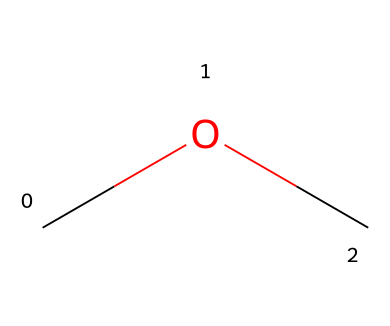What is the molecular formula of this compound? The SMILES representation "COC" indicates that there are 2 carbon atoms (C), 6 hydrogen atoms (H), and 1 oxygen atom (O) in the structure. Therefore, the molecular formula is C2H6O.
Answer: C2H6O How many carbon atoms are present in dimethyl ether? The chemical structure as represented by the SMILES shows two "C" (carbon) symbols, which means there are a total of 2 carbon atoms in dimethyl ether.
Answer: 2 What type of bonding is present in this ether? The representation shows single bonds between carbon and oxygen, suggesting that the ether has covalent bonding typical of ethers where carbon atoms are bonded to an oxygen atom.
Answer: covalent What functional group is characteristic of dimethyl ether? In the chemical structure, the oxygen atom connects the two carbon atoms, which identifies the structure as an ether, characterized by the R-O-R' functional group.
Answer: ether What is the boiling point range of dimethyl ether? Dimethyl ether typically has a boiling point around -24 degrees Celsius, which is derived from its molecular properties and structure.
Answer: -24 °C In what applications is dimethyl ether commonly used? Dimethyl ether is often utilized as a propellant in aerosol systems due to its effective vapor pressure and low toxicity, making it suitable for cleaning electronic equipment.
Answer: aerosol propellant 